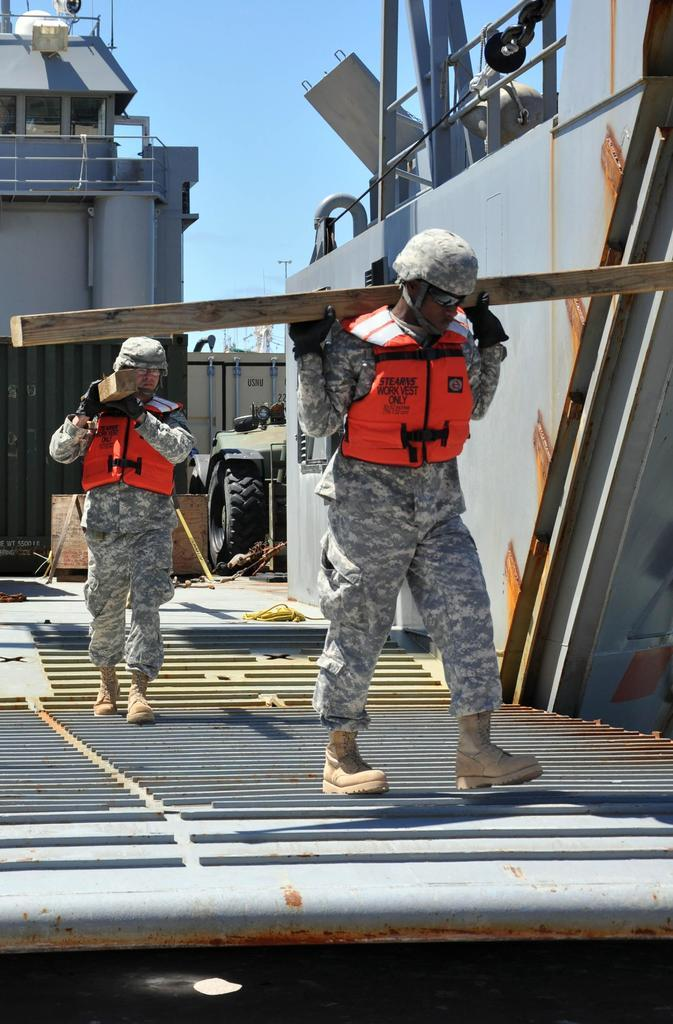What can be seen in the image? There are men in the image. What are the men doing? The men are walking and holding wooden planks. Where does the scene appear to take place? The scene appears to be on a ship. What is the color of the sky in the image? The sky is blue in the image. What type of chairs are visible on the ship in the image? There are no chairs visible in the image; the men are holding wooden planks. What is the title of the image? The image does not have a title, as it is a photograph or illustration and not a piece of literature or art with a specific title. 